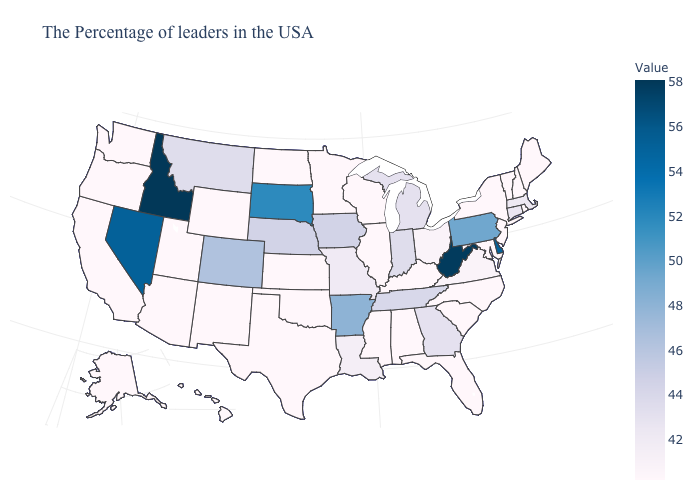Among the states that border Pennsylvania , which have the highest value?
Keep it brief. West Virginia. Which states have the highest value in the USA?
Be succinct. Idaho. Which states have the lowest value in the USA?
Keep it brief. Maine, Rhode Island, New Hampshire, Vermont, New York, New Jersey, Maryland, North Carolina, South Carolina, Florida, Kentucky, Alabama, Wisconsin, Illinois, Mississippi, Minnesota, Kansas, Oklahoma, Texas, North Dakota, Wyoming, New Mexico, Utah, Arizona, California, Washington, Oregon, Alaska, Hawaii. Which states have the highest value in the USA?
Quick response, please. Idaho. Does Iowa have the lowest value in the USA?
Keep it brief. No. Which states have the lowest value in the West?
Short answer required. Wyoming, New Mexico, Utah, Arizona, California, Washington, Oregon, Alaska, Hawaii. 